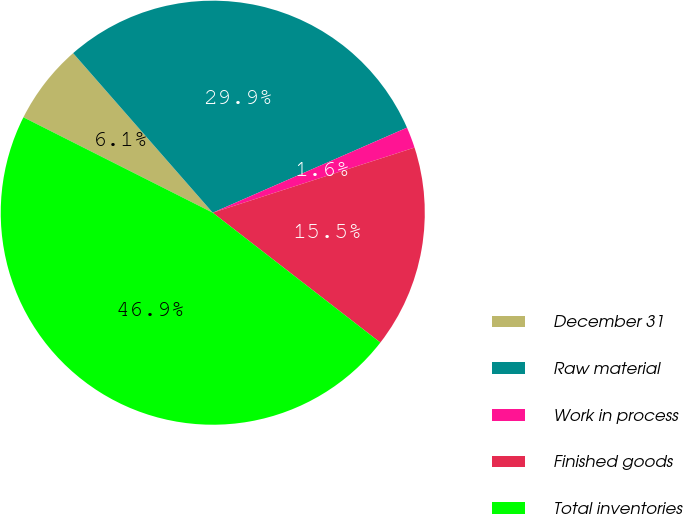<chart> <loc_0><loc_0><loc_500><loc_500><pie_chart><fcel>December 31<fcel>Raw material<fcel>Work in process<fcel>Finished goods<fcel>Total inventories<nl><fcel>6.13%<fcel>29.87%<fcel>1.6%<fcel>15.46%<fcel>46.93%<nl></chart> 